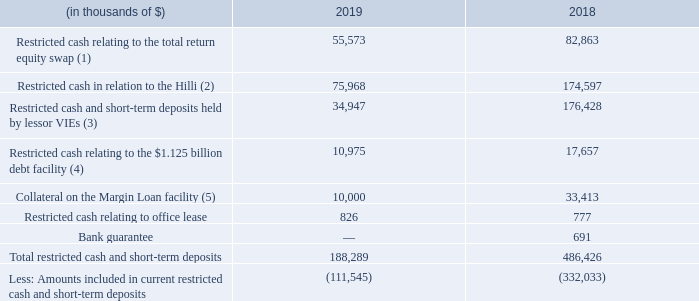12. RESTRICTED CASH AND SHORT-TERM DEPOSITS
Our restricted cash and short-term deposits balances are as follows:
(1) Restricted cash relating to the share repurchase forward swap refers to the collateral required by the bank with whom we entered into a total return equity swap. Collateral of 20% of the total purchase price is required and this is subsequently adjusted with reference to the Company's share price. In November 2019, we purchased 1.5 million shares underlying the total return equity swap that resulted in $54.7 million of restricted cash being released (see note 24).
(2) In November 2015, in connection with the issuance of a $400 million letter of credit by a financial institution to our project partner involved in the Hilli FLNG project, we posted an initial cash collateral sum of $305.0 million to support the performance guarantee.
Under the provisions of the $400 million letter of credit, the terms allow for a stepped reduction in the value of the guarantee over time and thus, conversely, a reduction in the cash collateral requirements. In 2017, the $400 million letter of credit and the cash collateral requirement was reduced to $300 million and $174.6 million, respectively, with no further reduction in 2018. In 2019, the letter of credit was reduced to $250.0 million and a contractual amendment further reduced the letter of credit to $125.0 million and the cash collateral to $76.0 million. There is no further contractual reduction expected until 2021.
In November 2016, after certain conditions precedent were satisfied by the Company, the letter of credit required in accordance with the signed LTA was re-issued and, with an initial expiry date of December 31, 2018, the letter of credit automatically extends, on an annual basis, until the tenth anniversary of the acceptance date of the Hilli by the charterer, unless the bank should exercise its option to exit from this arrangement by giving three months' notice prior to the annual renewal date.
(3) These are amounts held by lessor VIE entities that we are required to consolidate under U.S. GAAP into our financial statements as VIEs (see note 5).
(4) This refers to cash deposits required under the $1.125 billion debt facility (see note 18). The covenant requires that, on the second anniversary of drawdown under the facility, where we fall below a prescribed EBITDA to debt service ratio, additional cash deposits with the financial institution are required to be made or maintained.
(5) Collateral held against the Margin Loan facility is required to satisfy one of the mandatory prepayment events within the facility, with this having been triggered when the closing price of the Golar Partners common units pledged by us as security for the obligations under the facility fell below a defined threshold. If certain requirements are met, the facility allows for the release of the collateral (see note 18).
Restricted cash does not include minimum consolidated cash balances of $50.0 million (see note 18) required to be maintained as part of the financial covenants for our loan facilities, as these amounts are included in "Cash and cash equivalents".
What does restricted cash relating to the share repurchase forward swap represent? Collateral required by the bank with whom we entered into a total return equity swap. How much letter of credit was issued by the financial institution in 2015? $400 million. In which years was the restricted cash and short-term deposits recorded for? 2019, 2018. In which year was the restricted cash relating to office lease higher? 826 > 777
Answer: 2019. What was the change in collateral on the Margin Loan facility between 2018 and 2019?
Answer scale should be: thousand. 10,000 - 33,413 
Answer: -23413. What was the percentage change in restricted cash in relation to the Hilli between 2018 and 2019?
Answer scale should be: percent. (75,968 - 174,597)/174,597 
Answer: -56.49. 